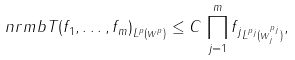<formula> <loc_0><loc_0><loc_500><loc_500>\ n r m b { T ( f _ { 1 } , \dots , f _ { m } ) } _ { L ^ { p } ( w ^ { p } ) } \leq C \, \prod _ { j = 1 } ^ { m } \| f _ { j } \| _ { L ^ { p _ { j } } ( w _ { j } ^ { p _ { j } } ) } ,</formula> 